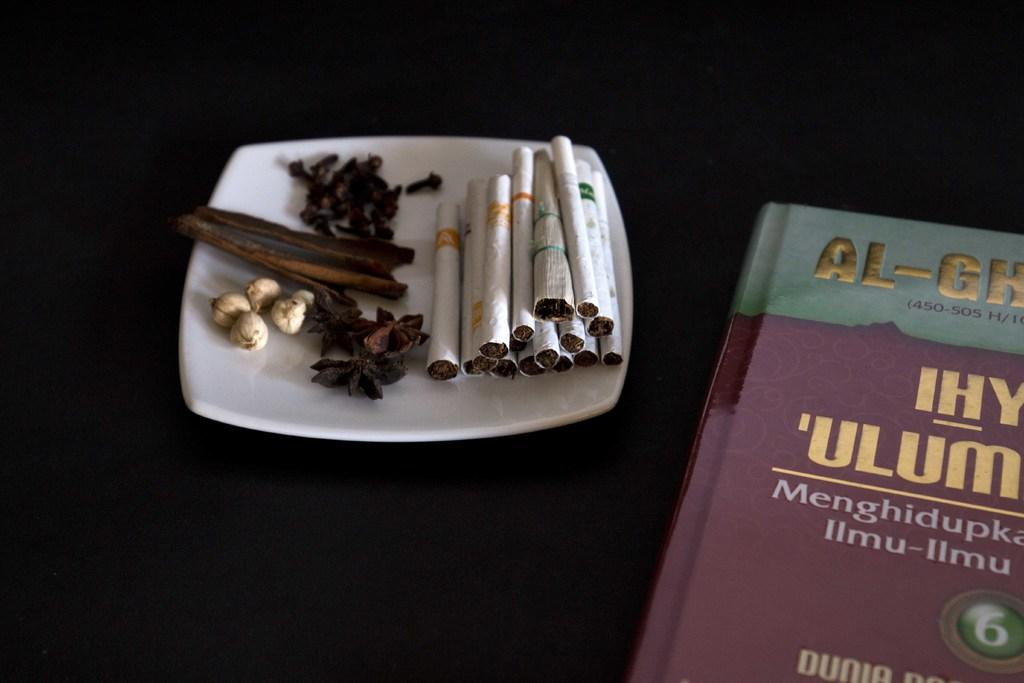<image>
Render a clear and concise summary of the photo. cigarettes and spices next to a book with letters AL-GH on the cover 